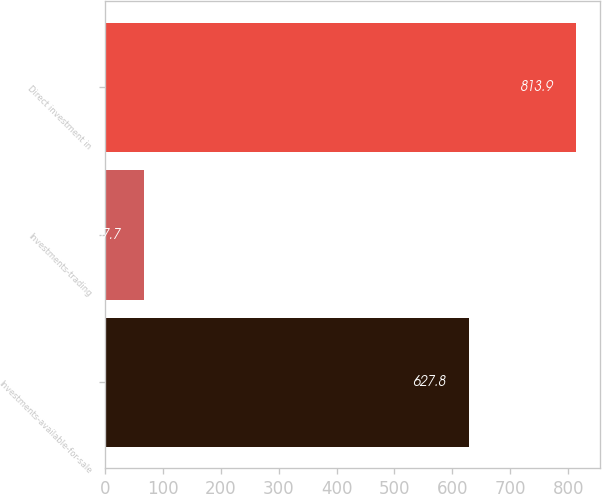<chart> <loc_0><loc_0><loc_500><loc_500><bar_chart><fcel>Investments-available-for-sale<fcel>Investments-trading<fcel>Direct investment in<nl><fcel>627.8<fcel>67.7<fcel>813.9<nl></chart> 